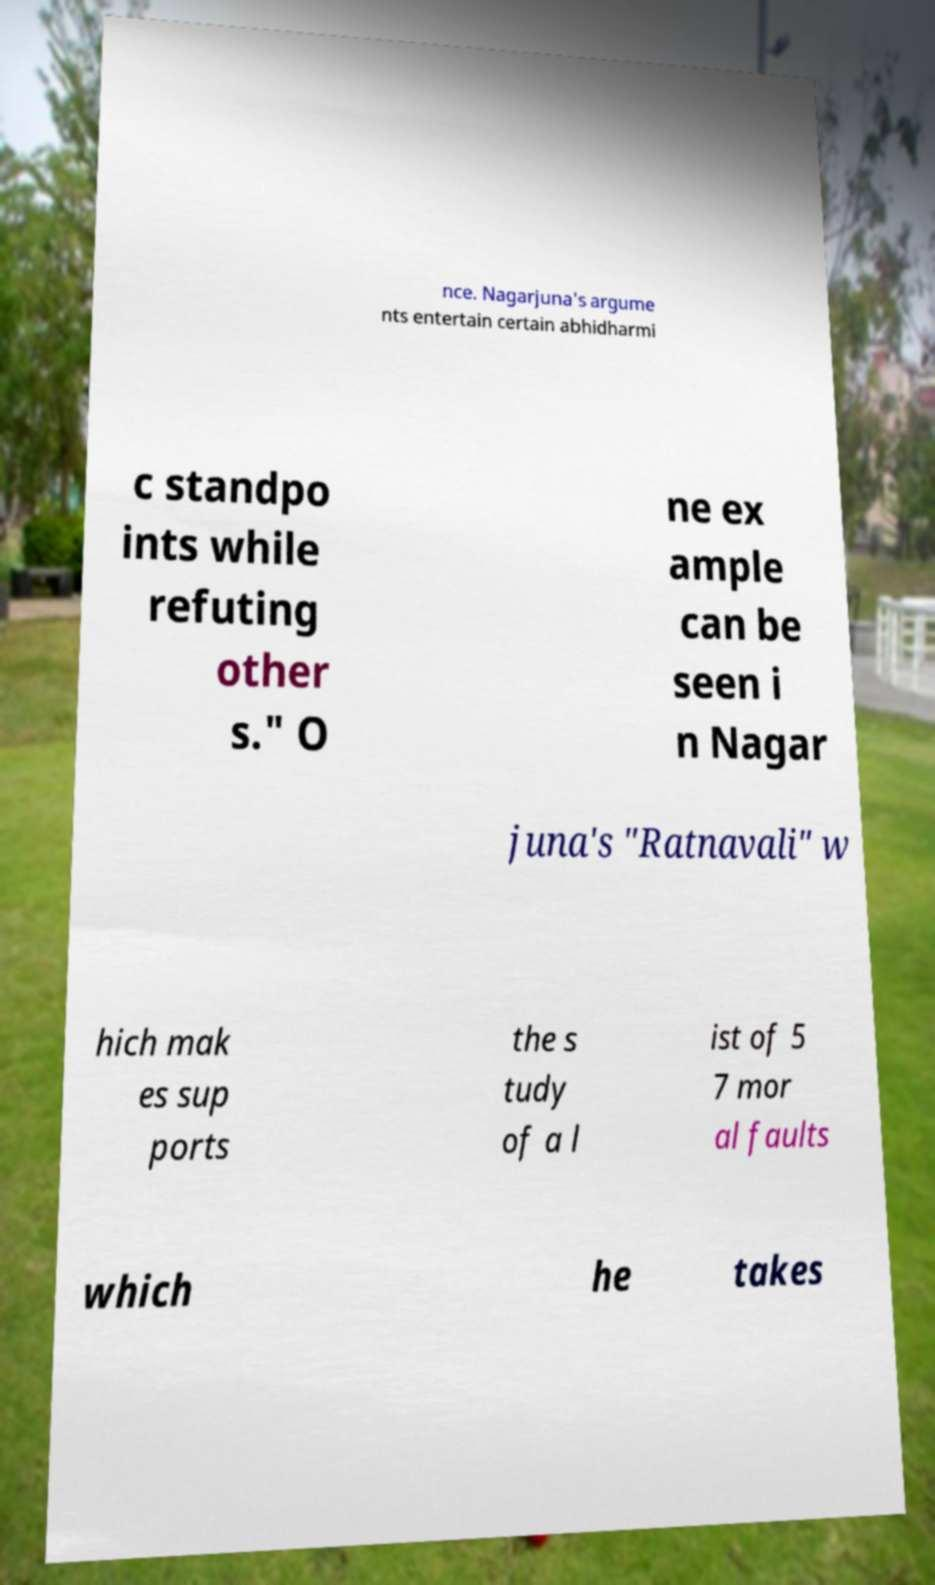Can you accurately transcribe the text from the provided image for me? nce. Nagarjuna's argume nts entertain certain abhidharmi c standpo ints while refuting other s." O ne ex ample can be seen i n Nagar juna's "Ratnavali" w hich mak es sup ports the s tudy of a l ist of 5 7 mor al faults which he takes 